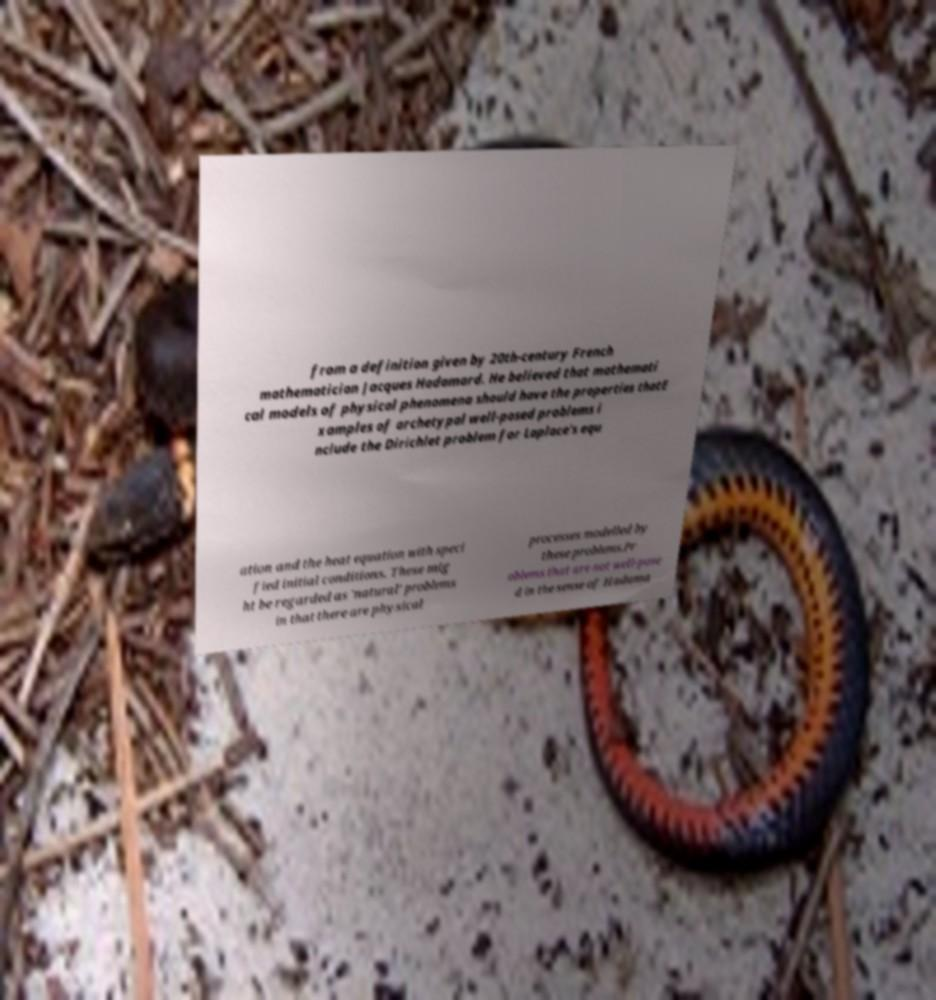What messages or text are displayed in this image? I need them in a readable, typed format. from a definition given by 20th-century French mathematician Jacques Hadamard. He believed that mathemati cal models of physical phenomena should have the properties thatE xamples of archetypal well-posed problems i nclude the Dirichlet problem for Laplace's equ ation and the heat equation with speci fied initial conditions. These mig ht be regarded as 'natural' problems in that there are physical processes modelled by these problems.Pr oblems that are not well-pose d in the sense of Hadama 